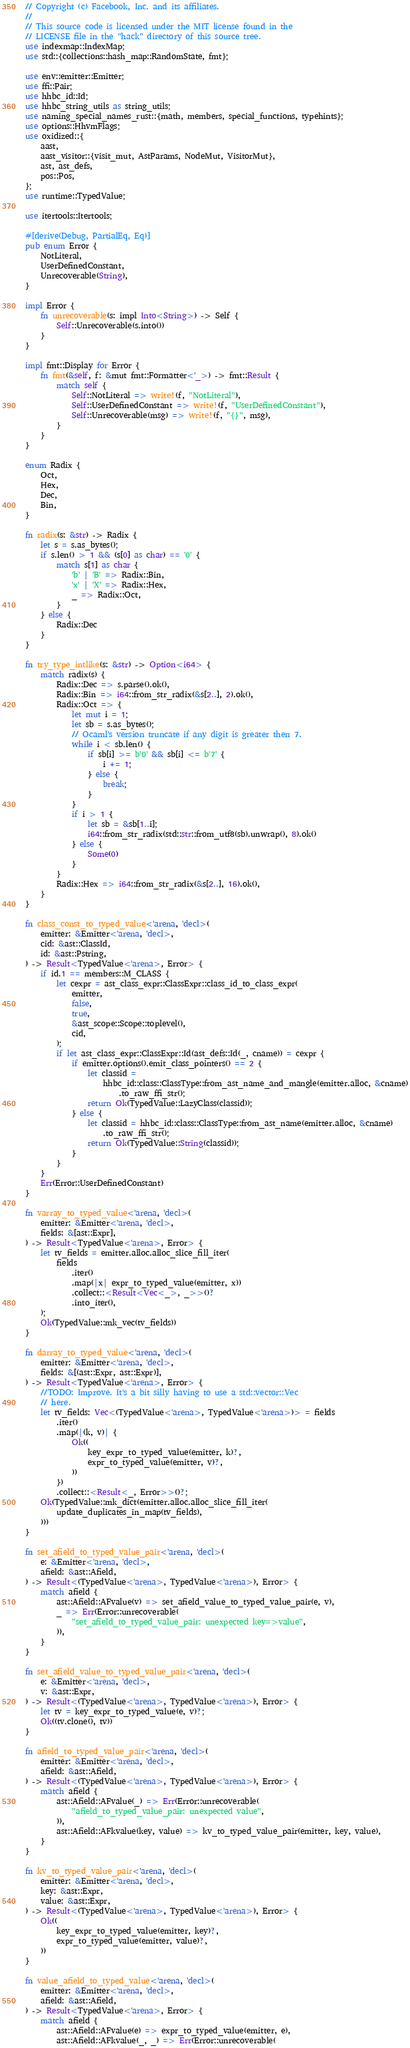Convert code to text. <code><loc_0><loc_0><loc_500><loc_500><_Rust_>// Copyright (c) Facebook, Inc. and its affiliates.
//
// This source code is licensed under the MIT license found in the
// LICENSE file in the "hack" directory of this source tree.
use indexmap::IndexMap;
use std::{collections::hash_map::RandomState, fmt};

use env::emitter::Emitter;
use ffi::Pair;
use hhbc_id::Id;
use hhbc_string_utils as string_utils;
use naming_special_names_rust::{math, members, special_functions, typehints};
use options::HhvmFlags;
use oxidized::{
    aast,
    aast_visitor::{visit_mut, AstParams, NodeMut, VisitorMut},
    ast, ast_defs,
    pos::Pos,
};
use runtime::TypedValue;

use itertools::Itertools;

#[derive(Debug, PartialEq, Eq)]
pub enum Error {
    NotLiteral,
    UserDefinedConstant,
    Unrecoverable(String),
}

impl Error {
    fn unrecoverable(s: impl Into<String>) -> Self {
        Self::Unrecoverable(s.into())
    }
}

impl fmt::Display for Error {
    fn fmt(&self, f: &mut fmt::Formatter<'_>) -> fmt::Result {
        match self {
            Self::NotLiteral => write!(f, "NotLiteral"),
            Self::UserDefinedConstant => write!(f, "UserDefinedConstant"),
            Self::Unrecoverable(msg) => write!(f, "{}", msg),
        }
    }
}

enum Radix {
    Oct,
    Hex,
    Dec,
    Bin,
}

fn radix(s: &str) -> Radix {
    let s = s.as_bytes();
    if s.len() > 1 && (s[0] as char) == '0' {
        match s[1] as char {
            'b' | 'B' => Radix::Bin,
            'x' | 'X' => Radix::Hex,
            _ => Radix::Oct,
        }
    } else {
        Radix::Dec
    }
}

fn try_type_intlike(s: &str) -> Option<i64> {
    match radix(s) {
        Radix::Dec => s.parse().ok(),
        Radix::Bin => i64::from_str_radix(&s[2..], 2).ok(),
        Radix::Oct => {
            let mut i = 1;
            let sb = s.as_bytes();
            // Ocaml's version truncate if any digit is greater then 7.
            while i < sb.len() {
                if sb[i] >= b'0' && sb[i] <= b'7' {
                    i += 1;
                } else {
                    break;
                }
            }
            if i > 1 {
                let sb = &sb[1..i];
                i64::from_str_radix(std::str::from_utf8(sb).unwrap(), 8).ok()
            } else {
                Some(0)
            }
        }
        Radix::Hex => i64::from_str_radix(&s[2..], 16).ok(),
    }
}

fn class_const_to_typed_value<'arena, 'decl>(
    emitter: &Emitter<'arena, 'decl>,
    cid: &ast::ClassId,
    id: &ast::Pstring,
) -> Result<TypedValue<'arena>, Error> {
    if id.1 == members::M_CLASS {
        let cexpr = ast_class_expr::ClassExpr::class_id_to_class_expr(
            emitter,
            false,
            true,
            &ast_scope::Scope::toplevel(),
            cid,
        );
        if let ast_class_expr::ClassExpr::Id(ast_defs::Id(_, cname)) = cexpr {
            if emitter.options().emit_class_pointers() == 2 {
                let classid =
                    hhbc_id::class::ClassType::from_ast_name_and_mangle(emitter.alloc, &cname)
                        .to_raw_ffi_str();
                return Ok(TypedValue::LazyClass(classid));
            } else {
                let classid = hhbc_id::class::ClassType::from_ast_name(emitter.alloc, &cname)
                    .to_raw_ffi_str();
                return Ok(TypedValue::String(classid));
            }
        }
    }
    Err(Error::UserDefinedConstant)
}

fn varray_to_typed_value<'arena, 'decl>(
    emitter: &Emitter<'arena, 'decl>,
    fields: &[ast::Expr],
) -> Result<TypedValue<'arena>, Error> {
    let tv_fields = emitter.alloc.alloc_slice_fill_iter(
        fields
            .iter()
            .map(|x| expr_to_typed_value(emitter, x))
            .collect::<Result<Vec<_>, _>>()?
            .into_iter(),
    );
    Ok(TypedValue::mk_vec(tv_fields))
}

fn darray_to_typed_value<'arena, 'decl>(
    emitter: &Emitter<'arena, 'decl>,
    fields: &[(ast::Expr, ast::Expr)],
) -> Result<TypedValue<'arena>, Error> {
    //TODO: Improve. It's a bit silly having to use a std::vector::Vec
    // here.
    let tv_fields: Vec<(TypedValue<'arena>, TypedValue<'arena>)> = fields
        .iter()
        .map(|(k, v)| {
            Ok((
                key_expr_to_typed_value(emitter, k)?,
                expr_to_typed_value(emitter, v)?,
            ))
        })
        .collect::<Result<_, Error>>()?;
    Ok(TypedValue::mk_dict(emitter.alloc.alloc_slice_fill_iter(
        update_duplicates_in_map(tv_fields),
    )))
}

fn set_afield_to_typed_value_pair<'arena, 'decl>(
    e: &Emitter<'arena, 'decl>,
    afield: &ast::Afield,
) -> Result<(TypedValue<'arena>, TypedValue<'arena>), Error> {
    match afield {
        ast::Afield::AFvalue(v) => set_afield_value_to_typed_value_pair(e, v),
        _ => Err(Error::unrecoverable(
            "set_afield_to_typed_value_pair: unexpected key=>value",
        )),
    }
}

fn set_afield_value_to_typed_value_pair<'arena, 'decl>(
    e: &Emitter<'arena, 'decl>,
    v: &ast::Expr,
) -> Result<(TypedValue<'arena>, TypedValue<'arena>), Error> {
    let tv = key_expr_to_typed_value(e, v)?;
    Ok((tv.clone(), tv))
}

fn afield_to_typed_value_pair<'arena, 'decl>(
    emitter: &Emitter<'arena, 'decl>,
    afield: &ast::Afield,
) -> Result<(TypedValue<'arena>, TypedValue<'arena>), Error> {
    match afield {
        ast::Afield::AFvalue(_) => Err(Error::unrecoverable(
            "afield_to_typed_value_pair: unexpected value",
        )),
        ast::Afield::AFkvalue(key, value) => kv_to_typed_value_pair(emitter, key, value),
    }
}

fn kv_to_typed_value_pair<'arena, 'decl>(
    emitter: &Emitter<'arena, 'decl>,
    key: &ast::Expr,
    value: &ast::Expr,
) -> Result<(TypedValue<'arena>, TypedValue<'arena>), Error> {
    Ok((
        key_expr_to_typed_value(emitter, key)?,
        expr_to_typed_value(emitter, value)?,
    ))
}

fn value_afield_to_typed_value<'arena, 'decl>(
    emitter: &Emitter<'arena, 'decl>,
    afield: &ast::Afield,
) -> Result<TypedValue<'arena>, Error> {
    match afield {
        ast::Afield::AFvalue(e) => expr_to_typed_value(emitter, e),
        ast::Afield::AFkvalue(_, _) => Err(Error::unrecoverable(</code> 